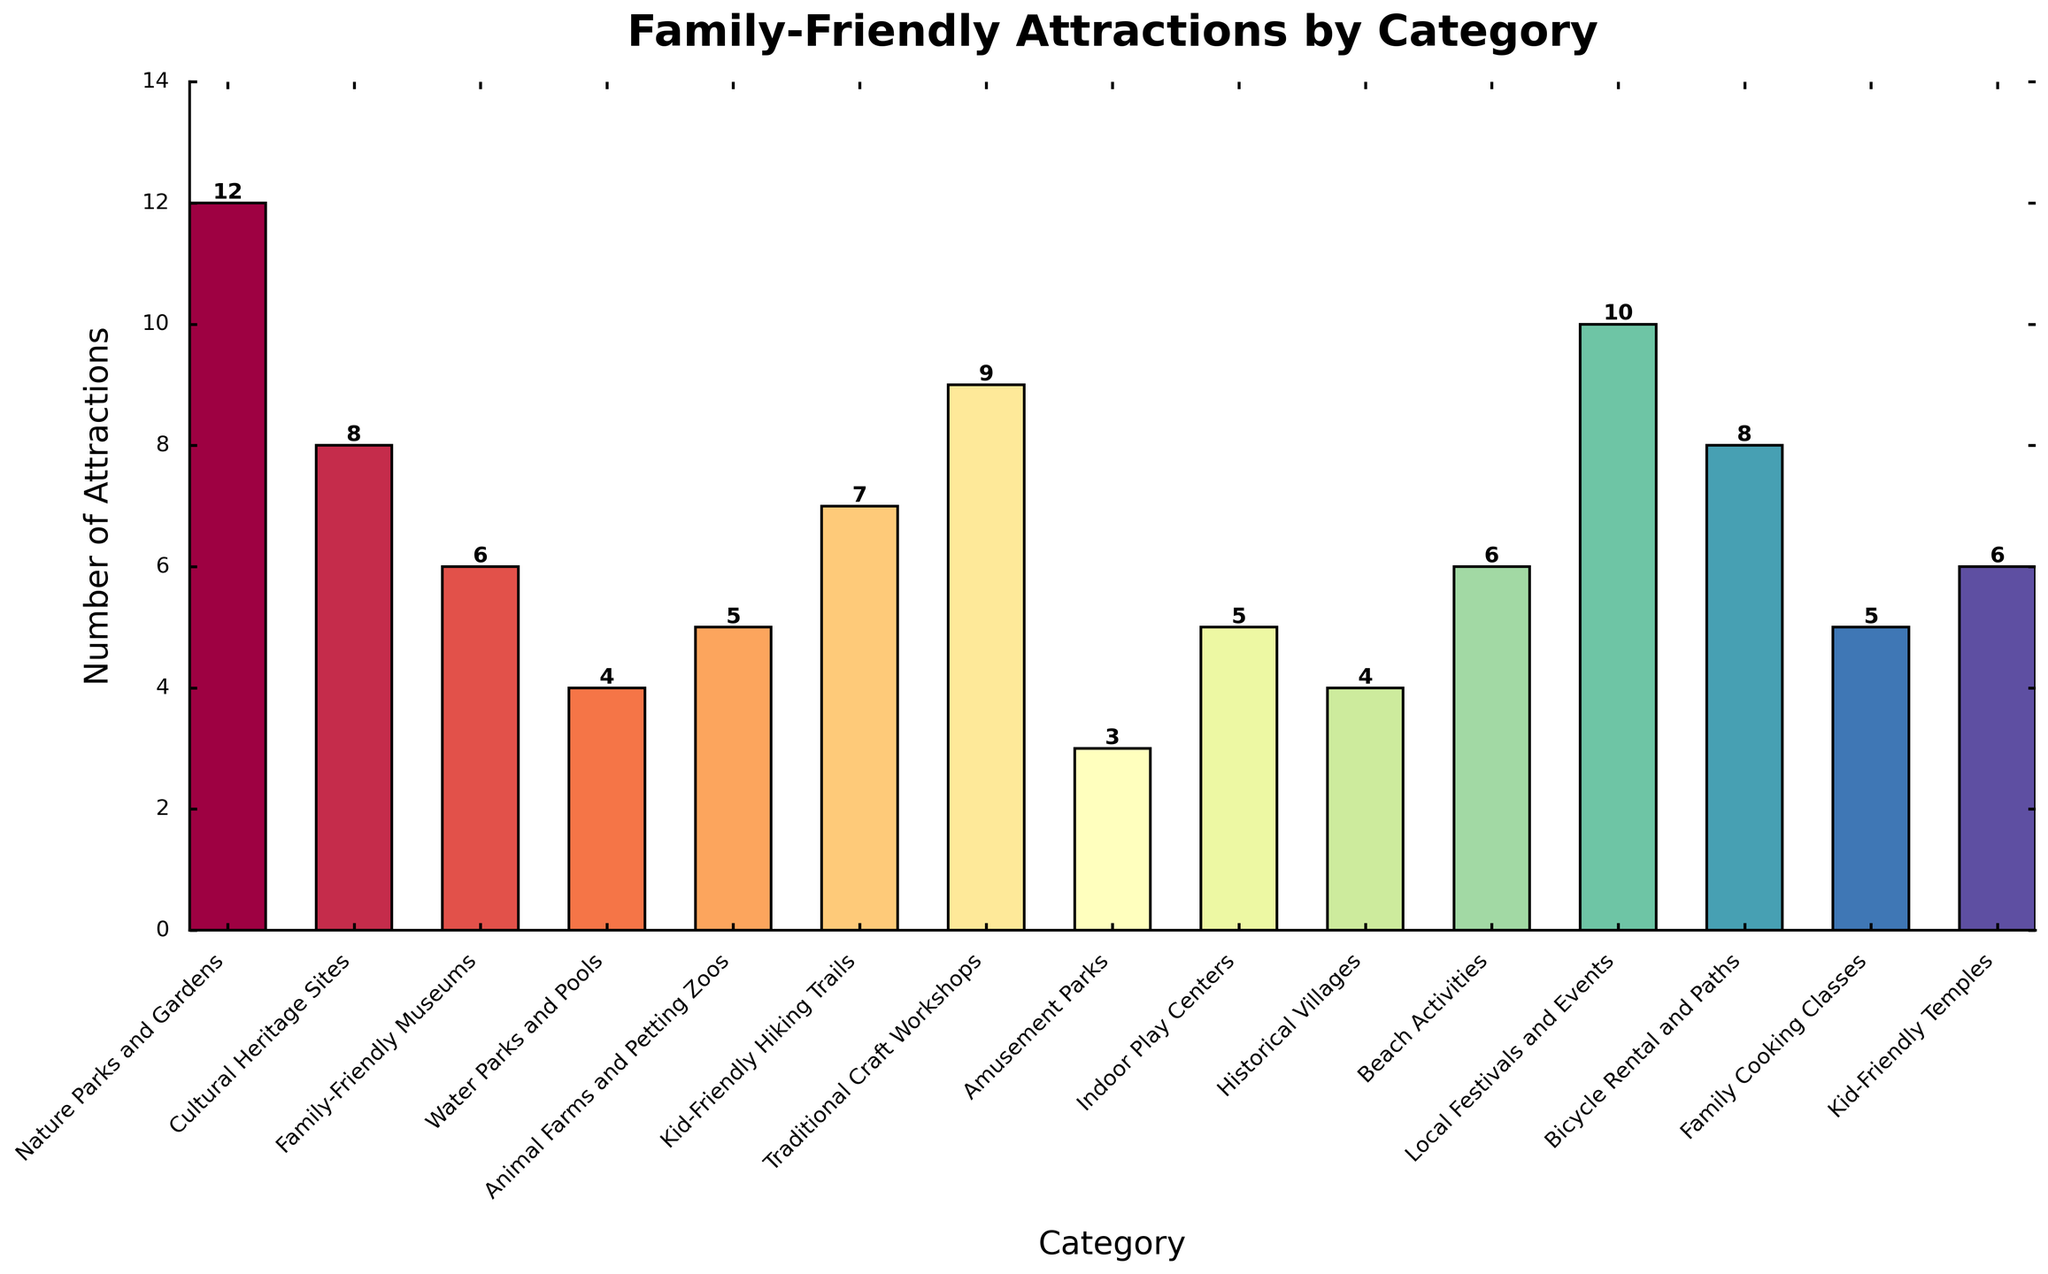Which category has the highest number of family-friendly attractions? The category with the tallest bar represents the highest number of attractions. "Nature Parks and Gardens" has the tallest bar.
Answer: Nature Parks and Gardens How many more attractions do Traditional Craft Workshops have compared to Indoor Play Centers? Identify the heights of both bars. Traditional Craft Workshops have 9 attractions, and Indoor Play Centers have 5. Subtract the smaller number from the larger: 9 - 5 = 4.
Answer: 4 What is the total number of attractions for categories with the word "Park" in their names? Identify the relevant categories: "Nature Parks and Gardens" (12), "Water Parks and Pools" (4), and "Amusement Parks" (3). Sum them up: 12 + 4 + 3 = 19.
Answer: 19 Which category has fewer attractions, Historical Villages or Beach Activities? Compare the heights of the bars for these categories. Historical Villages have 4 attractions and Beach Activities have 6. Historical Villages have fewer.
Answer: Historical Villages What is the average number of attractions per category? Sum the number of attractions for all categories and divide by the number of categories. The total is 98 (sum of all listed attractions), and there are 15 categories. 98 / 15 = 6.53 (rounded to two decimal places).
Answer: 6.53 How many categories have at least 7 attractions? Count the bars whose heights are 7 or higher: Nature Parks and Gardens (12), Cultural Heritage Sites (8), Traditional Craft Workshops (9), Local Festivals and Events (10), and Kid-Friendly Hiking Trails (7). There are 5 such categories.
Answer: 5 What's the combined number of attractions for family-friendly museums and kid-friendly temples? Identify the heights of both bars: Family-Friendly Museums (6) and Kid-Friendly Temples (6). Sum them up: 6 + 6 = 12.
Answer: 12 Which has more attractions, Family Cooking Classes or Animal Farms and Petting Zoos? Compare the heights of the bars. Family Cooking Classes and Animal Farms and Petting Zoos both have 5 attractions, so they have an equal number.
Answer: Equal What is the difference between the number of attractions in Local Festivals and Events and Amusement Parks? Local Festivals and Events have 10 attractions, and Amusement Parks have 3. Subtract the smaller number from the larger: 10 - 3 = 7.
Answer: 7 